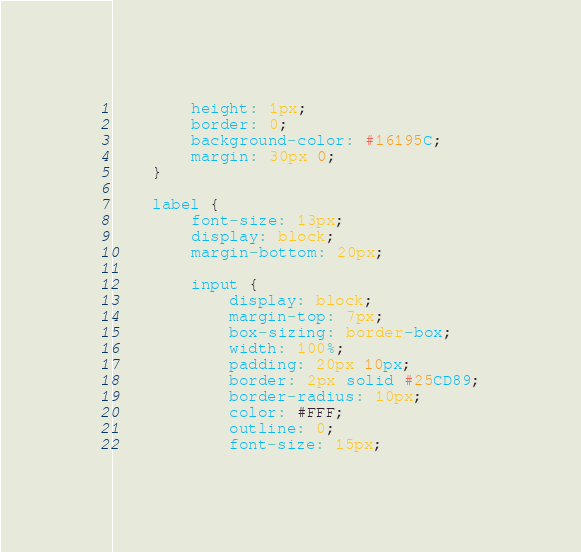Convert code to text. <code><loc_0><loc_0><loc_500><loc_500><_TypeScript_>        height: 1px;
        border: 0;
        background-color: #16195C;
        margin: 30px 0;
    }

    label {
        font-size: 13px;
        display: block;
        margin-bottom: 20px;

        input {
            display: block;
            margin-top: 7px;
            box-sizing: border-box;
            width: 100%;
            padding: 20px 10px;
            border: 2px solid #25CD89;
            border-radius: 10px;
            color: #FFF;
            outline: 0;
            font-size: 15px;</code> 